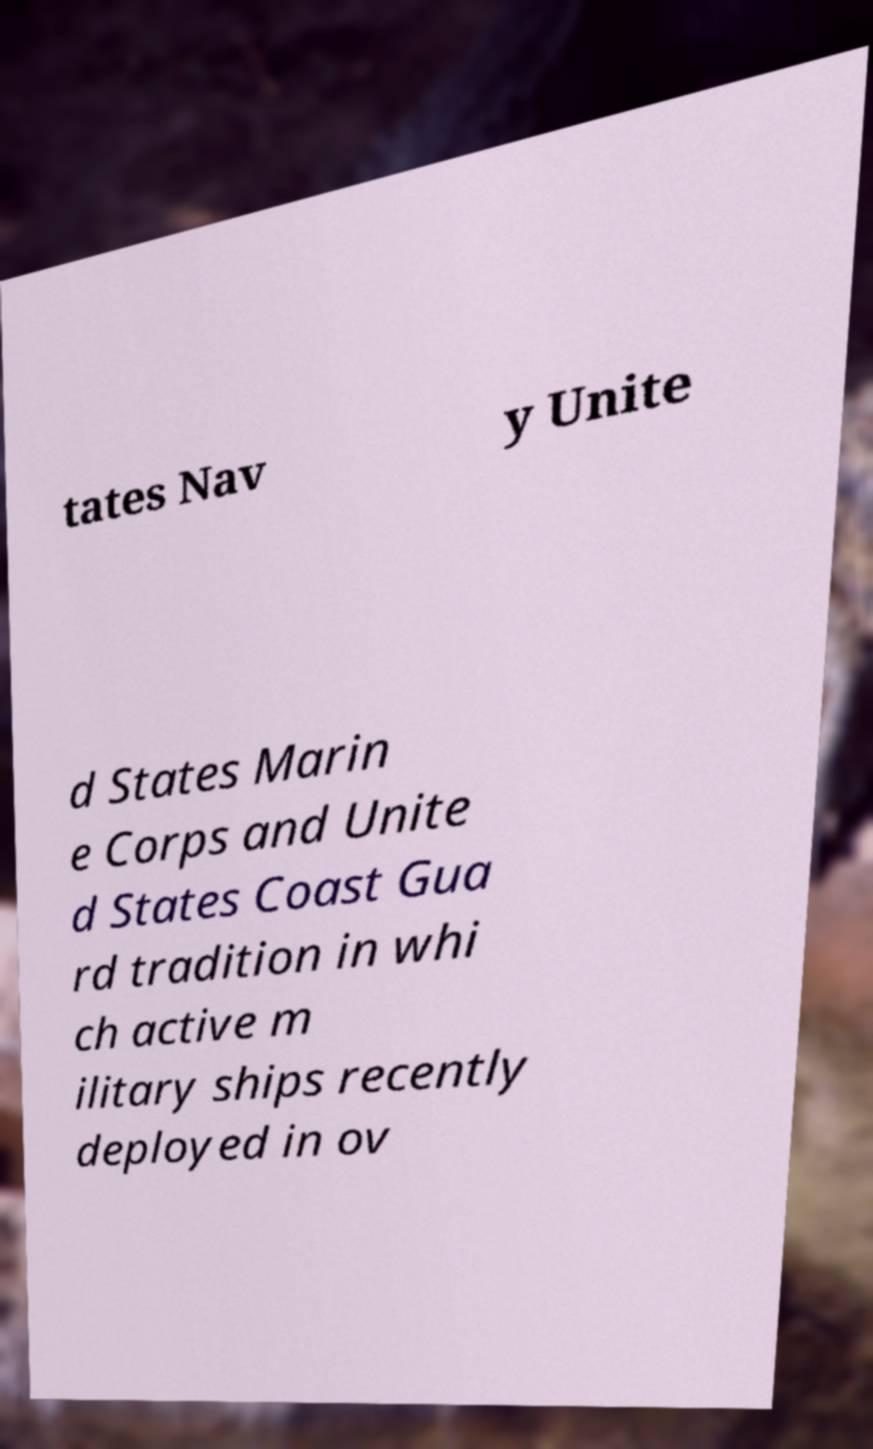Could you extract and type out the text from this image? tates Nav y Unite d States Marin e Corps and Unite d States Coast Gua rd tradition in whi ch active m ilitary ships recently deployed in ov 